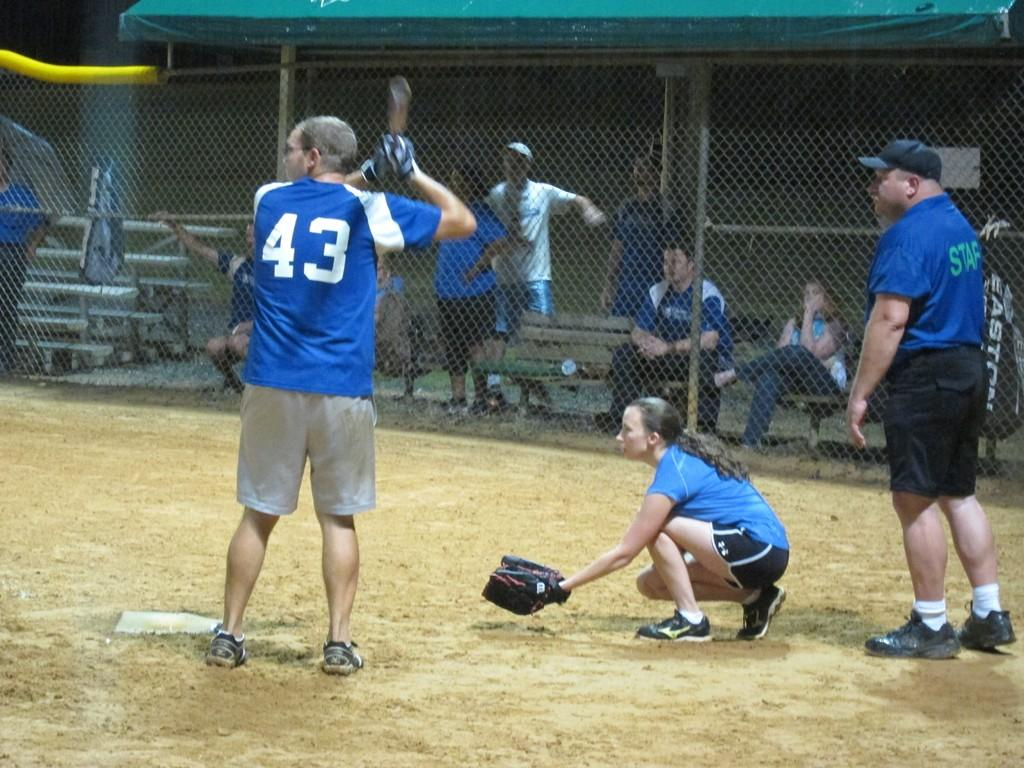<image>
Share a concise interpretation of the image provided. the number 43 is on the back of the blue jersey 